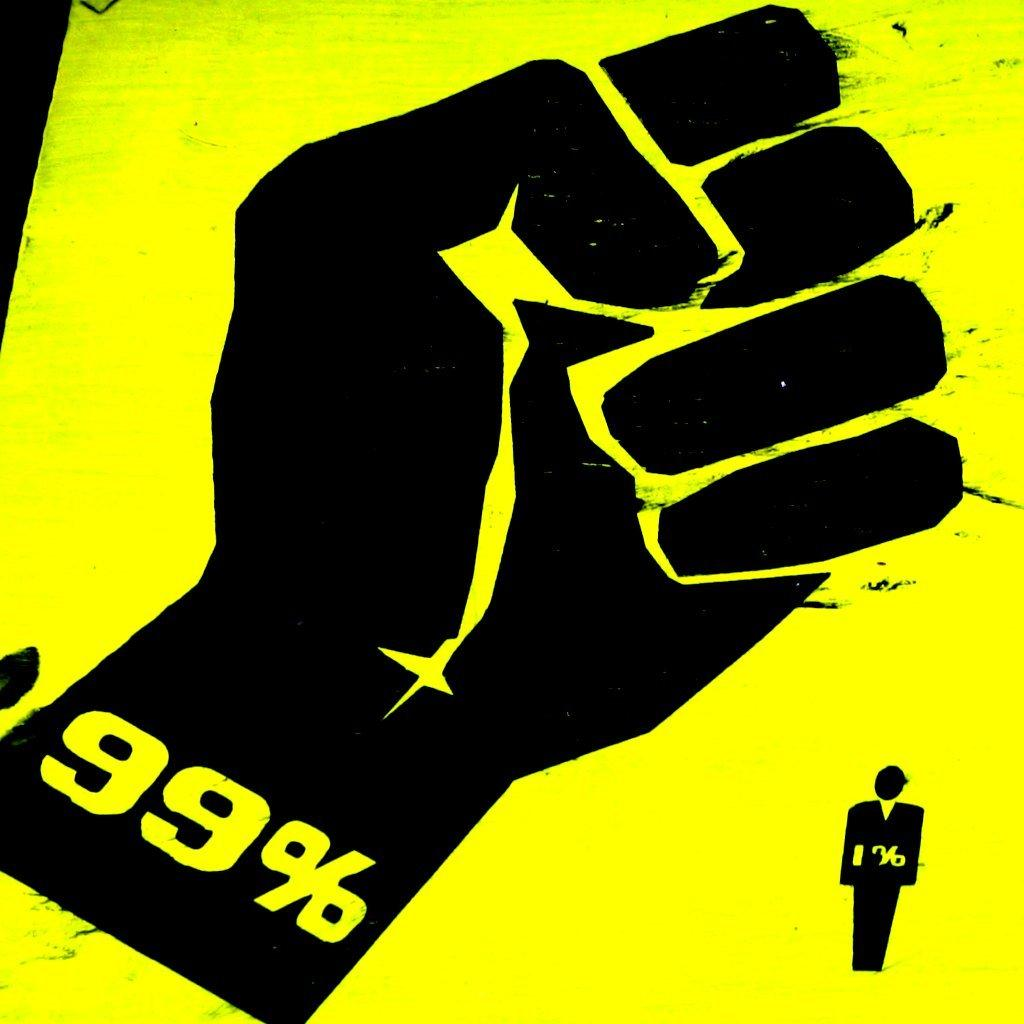What is the main subject in the center of the image? There is a poster in the center of the image. What is depicted on the poster? The poster contains a symbol of a person and a hand symbol of a person. What additional information is present on the hand symbol? There are numbers and percentages on the hand symbol. What type of feast is being prepared in the image? There is no feast being prepared in the image; it only contains a poster with symbols and numbers. Is the poster framed in the image? The provided facts do not mention a frame, so we cannot determine if the poster is framed or not. 